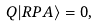Convert formula to latex. <formula><loc_0><loc_0><loc_500><loc_500>Q | R P A \rangle = 0 ,</formula> 